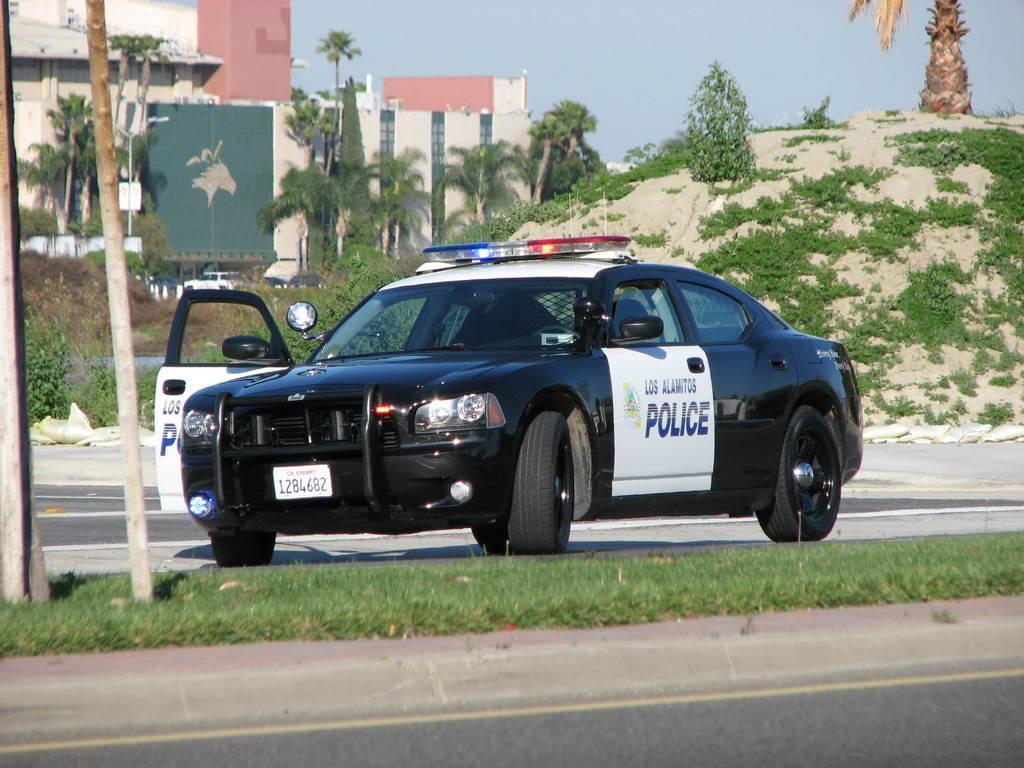Describe this image in one or two sentences. This image is taken outdoors. At the bottom of the image there is a road and a ground with grass on it. In the middle of the image a car is parked on the road. On the left side of the image there are two poles. In the background there are a few buildings and there are many trees and plants. On the right side of the image there is a hill with a few plants and a tree on it. 